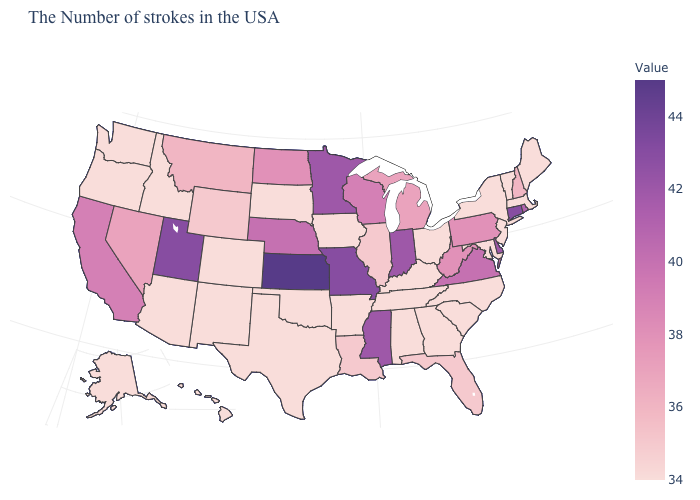Does Maine have the lowest value in the USA?
Be succinct. Yes. Is the legend a continuous bar?
Short answer required. Yes. Among the states that border Delaware , does New Jersey have the highest value?
Quick response, please. No. Among the states that border Idaho , which have the lowest value?
Write a very short answer. Washington, Oregon. Among the states that border Texas , does Oklahoma have the highest value?
Keep it brief. No. Which states have the lowest value in the MidWest?
Short answer required. Ohio, Iowa, South Dakota. Does Wisconsin have a lower value than Massachusetts?
Concise answer only. No. Does Alaska have the lowest value in the West?
Quick response, please. Yes. 